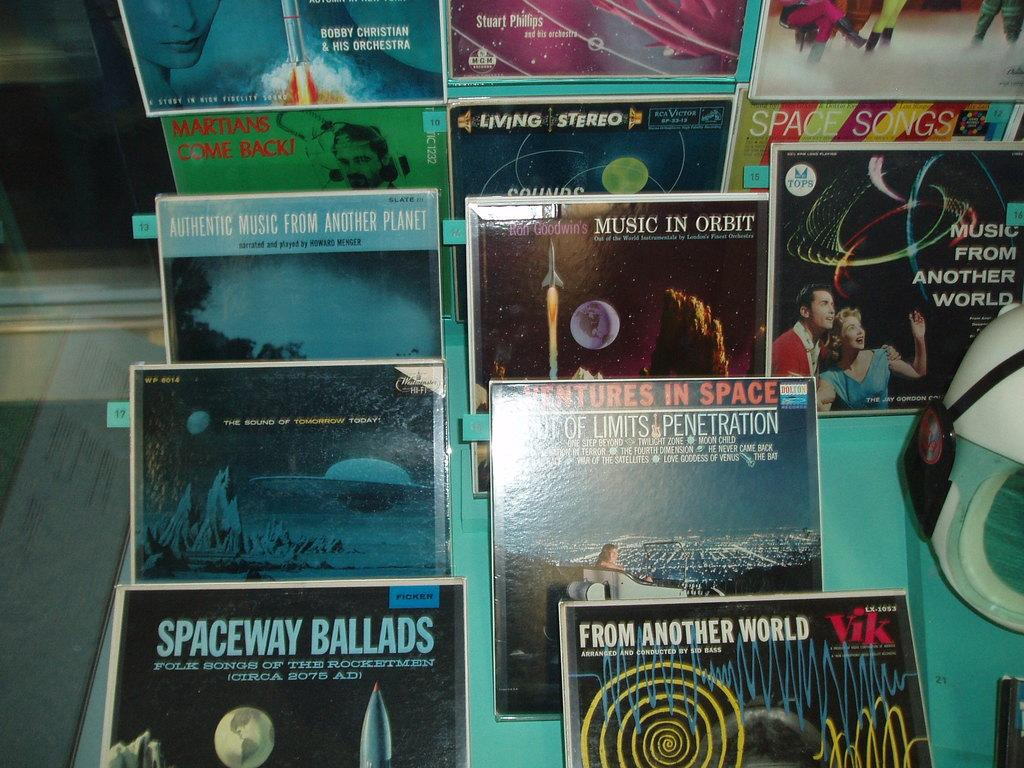<image>
Write a terse but informative summary of the picture. Spaceway Ballads is one type of album on display. 